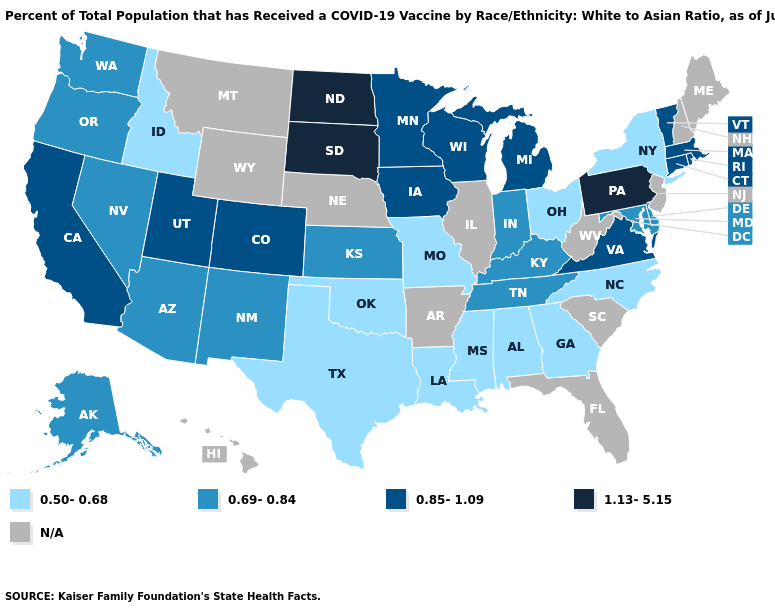Does the first symbol in the legend represent the smallest category?
Give a very brief answer. Yes. Name the states that have a value in the range N/A?
Short answer required. Arkansas, Florida, Hawaii, Illinois, Maine, Montana, Nebraska, New Hampshire, New Jersey, South Carolina, West Virginia, Wyoming. What is the lowest value in the USA?
Give a very brief answer. 0.50-0.68. What is the value of Iowa?
Answer briefly. 0.85-1.09. What is the highest value in states that border Nebraska?
Short answer required. 1.13-5.15. How many symbols are there in the legend?
Short answer required. 5. What is the value of Delaware?
Give a very brief answer. 0.69-0.84. What is the lowest value in the MidWest?
Give a very brief answer. 0.50-0.68. What is the lowest value in the MidWest?
Short answer required. 0.50-0.68. Name the states that have a value in the range 1.13-5.15?
Answer briefly. North Dakota, Pennsylvania, South Dakota. Which states hav the highest value in the South?
Concise answer only. Virginia. What is the lowest value in the West?
Answer briefly. 0.50-0.68. What is the value of West Virginia?
Quick response, please. N/A. Which states have the highest value in the USA?
Concise answer only. North Dakota, Pennsylvania, South Dakota. 